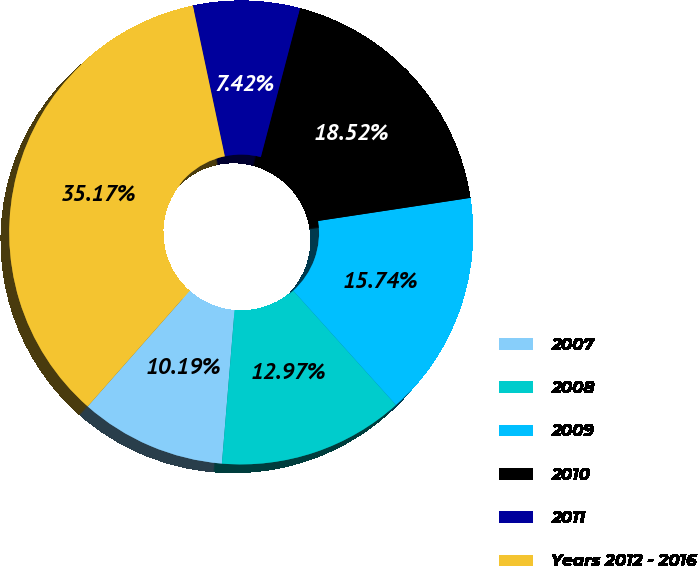Convert chart to OTSL. <chart><loc_0><loc_0><loc_500><loc_500><pie_chart><fcel>2007<fcel>2008<fcel>2009<fcel>2010<fcel>2011<fcel>Years 2012 - 2016<nl><fcel>10.19%<fcel>12.97%<fcel>15.74%<fcel>18.52%<fcel>7.42%<fcel>35.17%<nl></chart> 